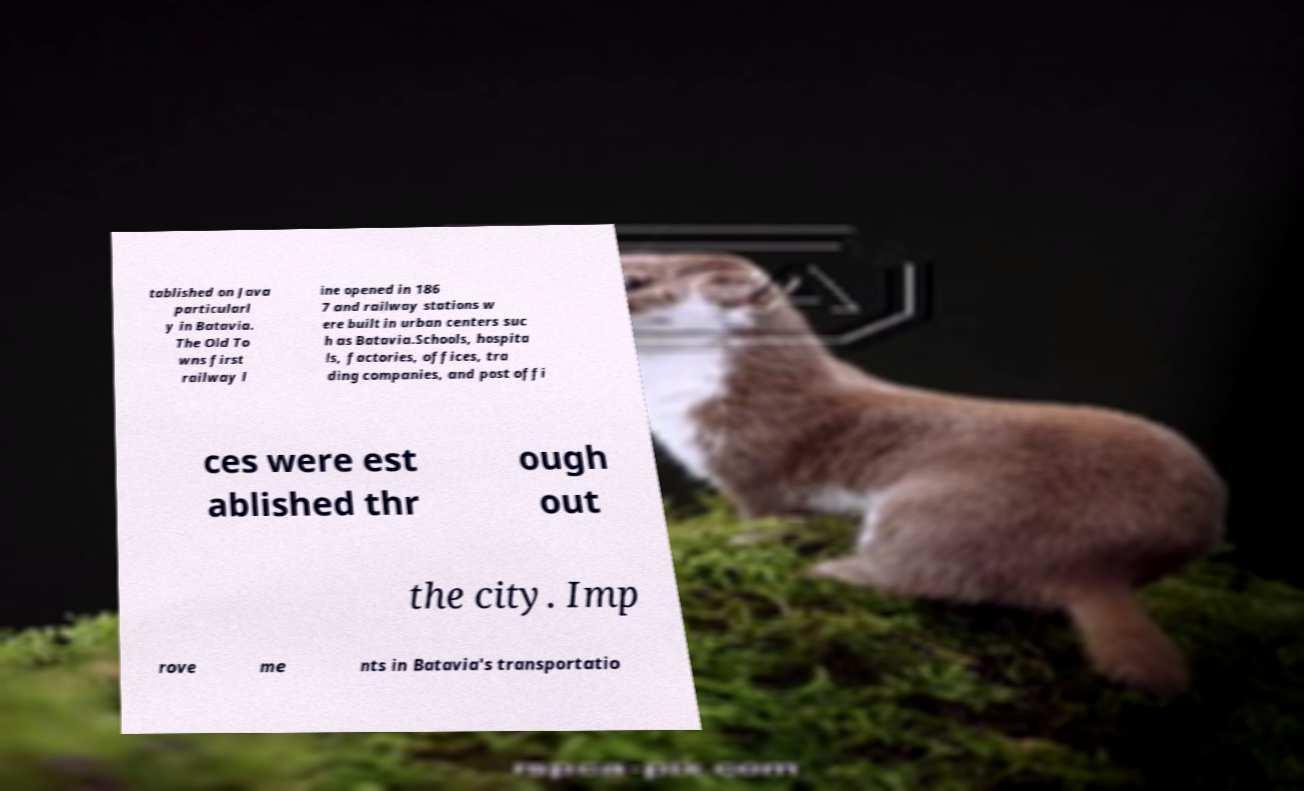Please read and relay the text visible in this image. What does it say? tablished on Java particularl y in Batavia. The Old To wns first railway l ine opened in 186 7 and railway stations w ere built in urban centers suc h as Batavia.Schools, hospita ls, factories, offices, tra ding companies, and post offi ces were est ablished thr ough out the city. Imp rove me nts in Batavia's transportatio 